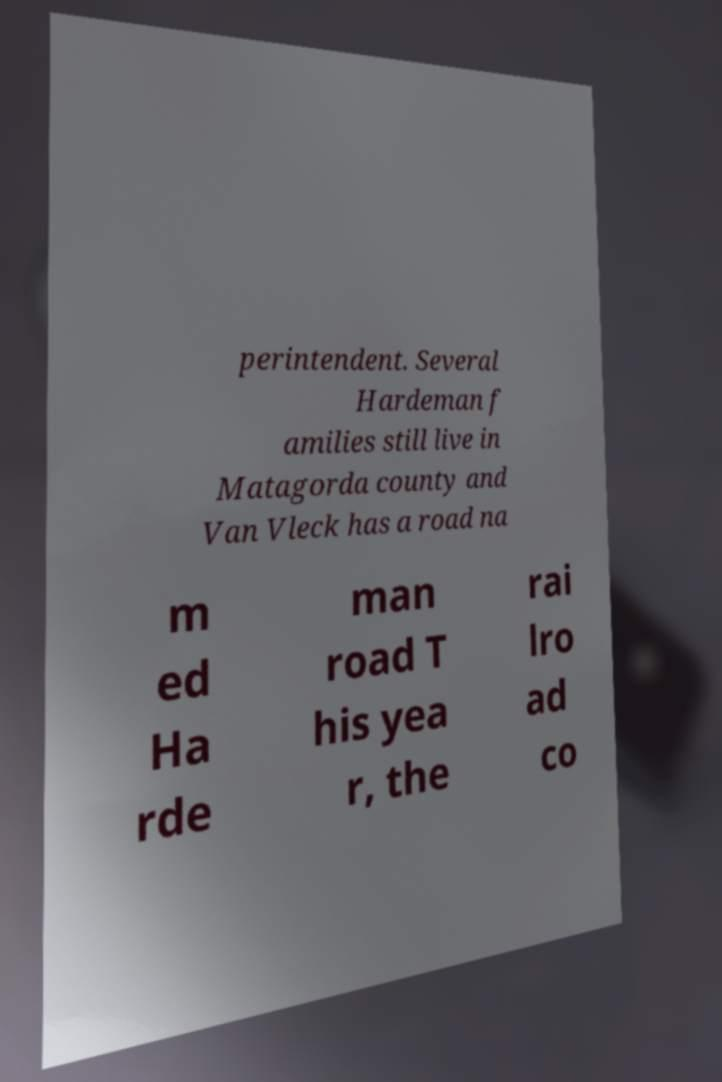Can you read and provide the text displayed in the image?This photo seems to have some interesting text. Can you extract and type it out for me? perintendent. Several Hardeman f amilies still live in Matagorda county and Van Vleck has a road na m ed Ha rde man road T his yea r, the rai lro ad co 